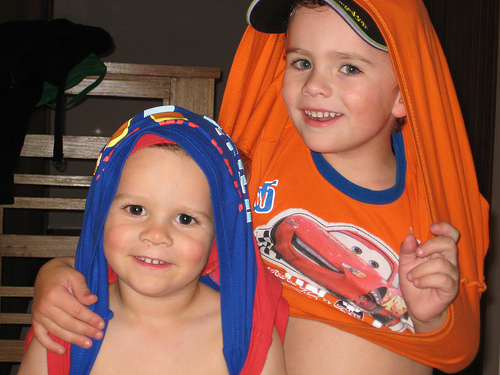<image>
Is there a boy to the left of the boy? Yes. From this viewpoint, the boy is positioned to the left side relative to the boy. Is the child in front of the child? Yes. The child is positioned in front of the child, appearing closer to the camera viewpoint. 